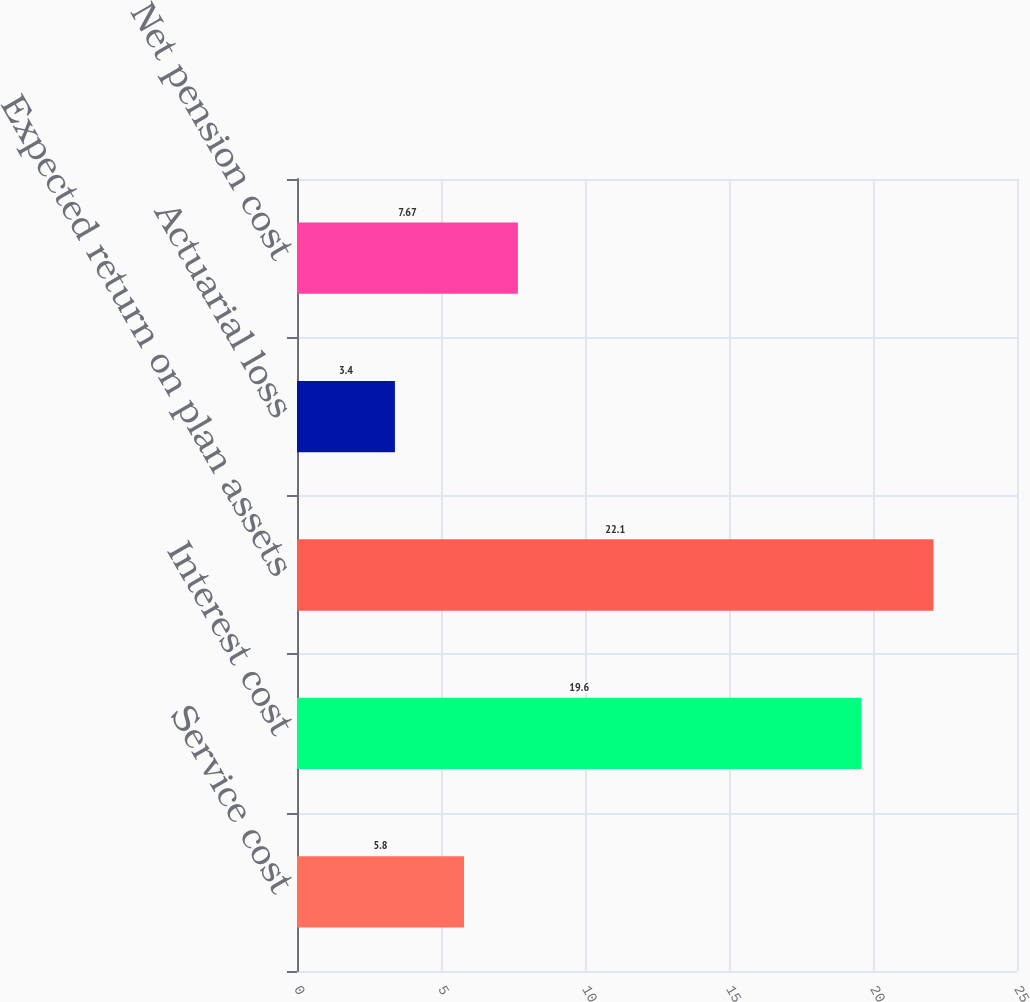Convert chart. <chart><loc_0><loc_0><loc_500><loc_500><bar_chart><fcel>Service cost<fcel>Interest cost<fcel>Expected return on plan assets<fcel>Actuarial loss<fcel>Net pension cost<nl><fcel>5.8<fcel>19.6<fcel>22.1<fcel>3.4<fcel>7.67<nl></chart> 